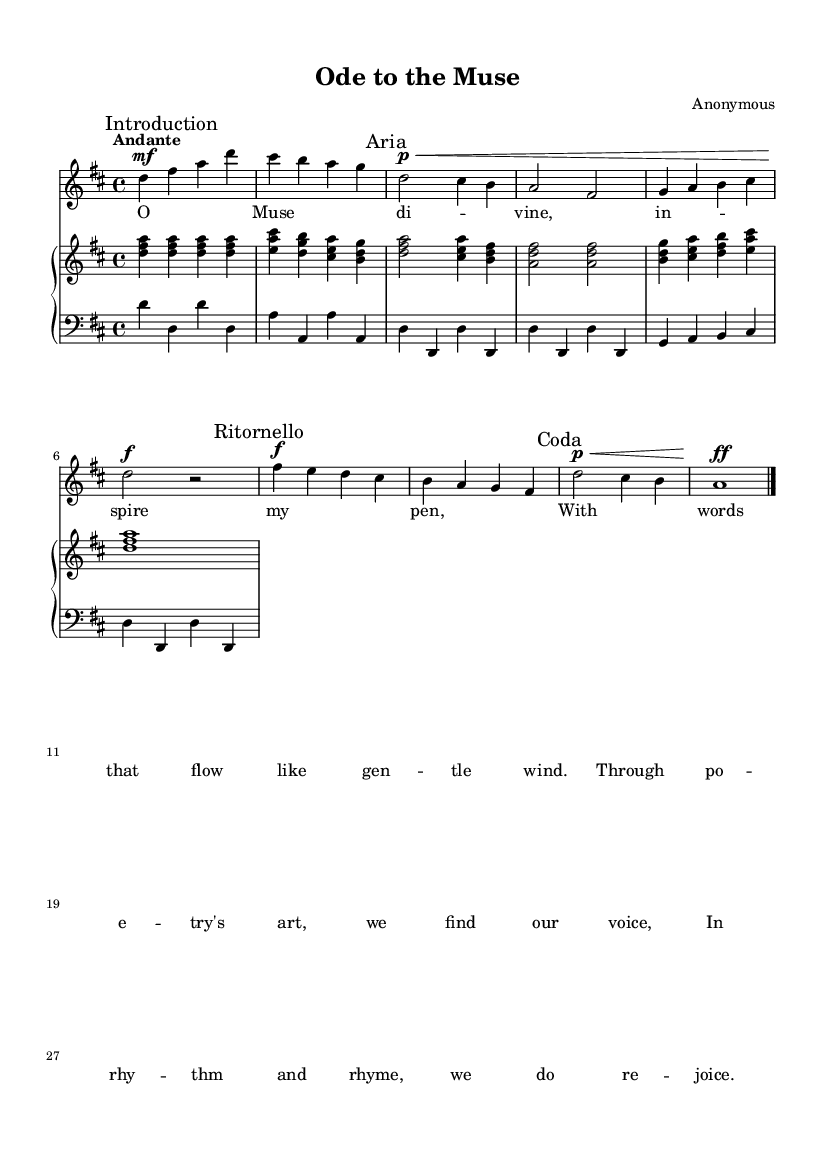What is the key signature of this music? The key signature is indicated at the beginning of the score, which features two sharps: F sharp and C sharp. This corresponds to the key of D major.
Answer: D major What is the time signature of this music? The time signature is found at the beginning of the score, expressed as 4/4, which means there are four beats in each measure and the quarter note gets one beat.
Answer: 4/4 What is the dynamic marking for the Aria section? The dynamic marking for the Aria section is indicated by the abbreviation "p" followed by the sign "\<", which denotes a soft volume (piano) that crescendos.
Answer: Piano How many measures are in the Ritornello section? The Ritornello section consists of four measures, as it begins with "Ritornello" and contains a total of four distinct musical phrases before moving to the Coda.
Answer: Four What is the tempo indication of the piece? The tempo indication is marked as "Andante" at the beginning of the score, suggesting a moderate walking pace.
Answer: Andante Which voice part has the lyrics included? The "soprano" part includes the lyrics, indicated by the presence of the "Lyrics" section beneath the "Voice" notation in the score.
Answer: Soprano What does the marking "Coda" signify in this piece? The marking "Coda" indicates the final section of the music, providing closure to the piece after the main themes have been presented.
Answer: Coda 